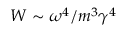<formula> <loc_0><loc_0><loc_500><loc_500>W \sim \omega ^ { 4 } / m ^ { 3 } \gamma ^ { 4 }</formula> 